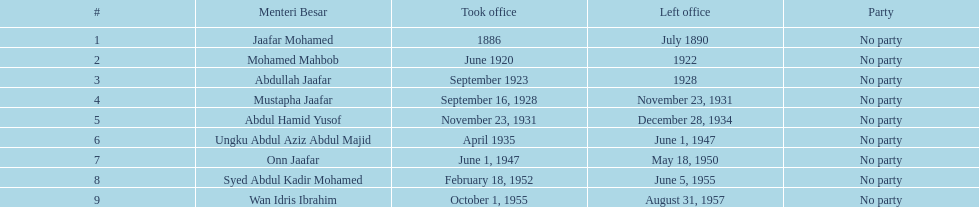How many years was jaafar mohamed in office? 4. 